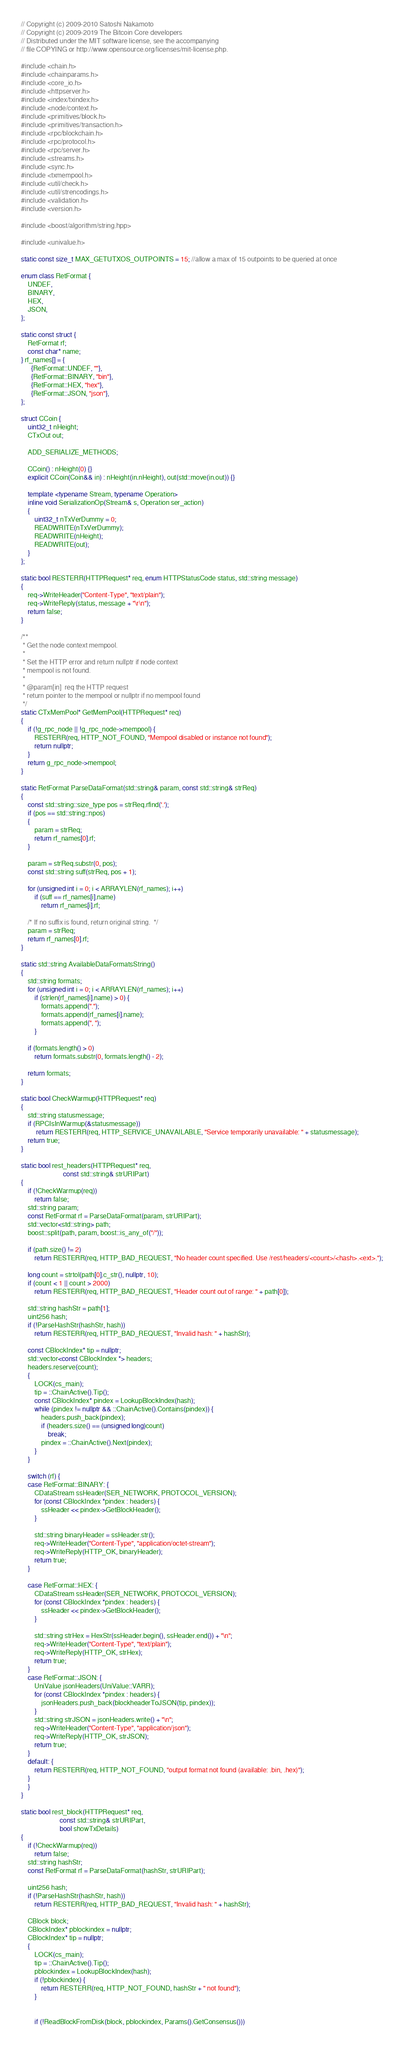Convert code to text. <code><loc_0><loc_0><loc_500><loc_500><_C++_>// Copyright (c) 2009-2010 Satoshi Nakamoto
// Copyright (c) 2009-2019 The Bitcoin Core developers
// Distributed under the MIT software license, see the accompanying
// file COPYING or http://www.opensource.org/licenses/mit-license.php.

#include <chain.h>
#include <chainparams.h>
#include <core_io.h>
#include <httpserver.h>
#include <index/txindex.h>
#include <node/context.h>
#include <primitives/block.h>
#include <primitives/transaction.h>
#include <rpc/blockchain.h>
#include <rpc/protocol.h>
#include <rpc/server.h>
#include <streams.h>
#include <sync.h>
#include <txmempool.h>
#include <util/check.h>
#include <util/strencodings.h>
#include <validation.h>
#include <version.h>

#include <boost/algorithm/string.hpp>

#include <univalue.h>

static const size_t MAX_GETUTXOS_OUTPOINTS = 15; //allow a max of 15 outpoints to be queried at once

enum class RetFormat {
    UNDEF,
    BINARY,
    HEX,
    JSON,
};

static const struct {
    RetFormat rf;
    const char* name;
} rf_names[] = {
      {RetFormat::UNDEF, ""},
      {RetFormat::BINARY, "bin"},
      {RetFormat::HEX, "hex"},
      {RetFormat::JSON, "json"},
};

struct CCoin {
    uint32_t nHeight;
    CTxOut out;

    ADD_SERIALIZE_METHODS;

    CCoin() : nHeight(0) {}
    explicit CCoin(Coin&& in) : nHeight(in.nHeight), out(std::move(in.out)) {}

    template <typename Stream, typename Operation>
    inline void SerializationOp(Stream& s, Operation ser_action)
    {
        uint32_t nTxVerDummy = 0;
        READWRITE(nTxVerDummy);
        READWRITE(nHeight);
        READWRITE(out);
    }
};

static bool RESTERR(HTTPRequest* req, enum HTTPStatusCode status, std::string message)
{
    req->WriteHeader("Content-Type", "text/plain");
    req->WriteReply(status, message + "\r\n");
    return false;
}

/**
 * Get the node context mempool.
 *
 * Set the HTTP error and return nullptr if node context
 * mempool is not found.
 *
 * @param[in]  req the HTTP request
 * return pointer to the mempool or nullptr if no mempool found
 */
static CTxMemPool* GetMemPool(HTTPRequest* req)
{
    if (!g_rpc_node || !g_rpc_node->mempool) {
        RESTERR(req, HTTP_NOT_FOUND, "Mempool disabled or instance not found");
        return nullptr;
    }
    return g_rpc_node->mempool;
}

static RetFormat ParseDataFormat(std::string& param, const std::string& strReq)
{
    const std::string::size_type pos = strReq.rfind('.');
    if (pos == std::string::npos)
    {
        param = strReq;
        return rf_names[0].rf;
    }

    param = strReq.substr(0, pos);
    const std::string suff(strReq, pos + 1);

    for (unsigned int i = 0; i < ARRAYLEN(rf_names); i++)
        if (suff == rf_names[i].name)
            return rf_names[i].rf;

    /* If no suffix is found, return original string.  */
    param = strReq;
    return rf_names[0].rf;
}

static std::string AvailableDataFormatsString()
{
    std::string formats;
    for (unsigned int i = 0; i < ARRAYLEN(rf_names); i++)
        if (strlen(rf_names[i].name) > 0) {
            formats.append(".");
            formats.append(rf_names[i].name);
            formats.append(", ");
        }

    if (formats.length() > 0)
        return formats.substr(0, formats.length() - 2);

    return formats;
}

static bool CheckWarmup(HTTPRequest* req)
{
    std::string statusmessage;
    if (RPCIsInWarmup(&statusmessage))
         return RESTERR(req, HTTP_SERVICE_UNAVAILABLE, "Service temporarily unavailable: " + statusmessage);
    return true;
}

static bool rest_headers(HTTPRequest* req,
                         const std::string& strURIPart)
{
    if (!CheckWarmup(req))
        return false;
    std::string param;
    const RetFormat rf = ParseDataFormat(param, strURIPart);
    std::vector<std::string> path;
    boost::split(path, param, boost::is_any_of("/"));

    if (path.size() != 2)
        return RESTERR(req, HTTP_BAD_REQUEST, "No header count specified. Use /rest/headers/<count>/<hash>.<ext>.");

    long count = strtol(path[0].c_str(), nullptr, 10);
    if (count < 1 || count > 2000)
        return RESTERR(req, HTTP_BAD_REQUEST, "Header count out of range: " + path[0]);

    std::string hashStr = path[1];
    uint256 hash;
    if (!ParseHashStr(hashStr, hash))
        return RESTERR(req, HTTP_BAD_REQUEST, "Invalid hash: " + hashStr);

    const CBlockIndex* tip = nullptr;
    std::vector<const CBlockIndex *> headers;
    headers.reserve(count);
    {
        LOCK(cs_main);
        tip = ::ChainActive().Tip();
        const CBlockIndex* pindex = LookupBlockIndex(hash);
        while (pindex != nullptr && ::ChainActive().Contains(pindex)) {
            headers.push_back(pindex);
            if (headers.size() == (unsigned long)count)
                break;
            pindex = ::ChainActive().Next(pindex);
        }
    }

    switch (rf) {
    case RetFormat::BINARY: {
        CDataStream ssHeader(SER_NETWORK, PROTOCOL_VERSION);
        for (const CBlockIndex *pindex : headers) {
            ssHeader << pindex->GetBlockHeader();
        }

        std::string binaryHeader = ssHeader.str();
        req->WriteHeader("Content-Type", "application/octet-stream");
        req->WriteReply(HTTP_OK, binaryHeader);
        return true;
    }

    case RetFormat::HEX: {
        CDataStream ssHeader(SER_NETWORK, PROTOCOL_VERSION);
        for (const CBlockIndex *pindex : headers) {
            ssHeader << pindex->GetBlockHeader();
        }

        std::string strHex = HexStr(ssHeader.begin(), ssHeader.end()) + "\n";
        req->WriteHeader("Content-Type", "text/plain");
        req->WriteReply(HTTP_OK, strHex);
        return true;
    }
    case RetFormat::JSON: {
        UniValue jsonHeaders(UniValue::VARR);
        for (const CBlockIndex *pindex : headers) {
            jsonHeaders.push_back(blockheaderToJSON(tip, pindex));
        }
        std::string strJSON = jsonHeaders.write() + "\n";
        req->WriteHeader("Content-Type", "application/json");
        req->WriteReply(HTTP_OK, strJSON);
        return true;
    }
    default: {
        return RESTERR(req, HTTP_NOT_FOUND, "output format not found (available: .bin, .hex)");
    }
    }
}

static bool rest_block(HTTPRequest* req,
                       const std::string& strURIPart,
                       bool showTxDetails)
{
    if (!CheckWarmup(req))
        return false;
    std::string hashStr;
    const RetFormat rf = ParseDataFormat(hashStr, strURIPart);

    uint256 hash;
    if (!ParseHashStr(hashStr, hash))
        return RESTERR(req, HTTP_BAD_REQUEST, "Invalid hash: " + hashStr);

    CBlock block;
    CBlockIndex* pblockindex = nullptr;
    CBlockIndex* tip = nullptr;
    {
        LOCK(cs_main);
        tip = ::ChainActive().Tip();
        pblockindex = LookupBlockIndex(hash);
        if (!pblockindex) {
            return RESTERR(req, HTTP_NOT_FOUND, hashStr + " not found");
        }


        if (!ReadBlockFromDisk(block, pblockindex, Params().GetConsensus()))</code> 